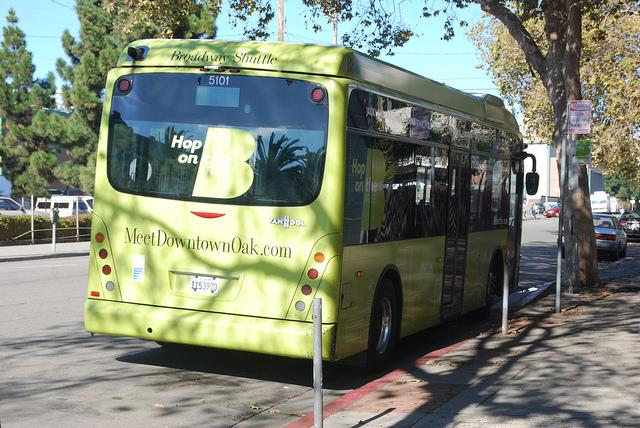What city is this? oakland 